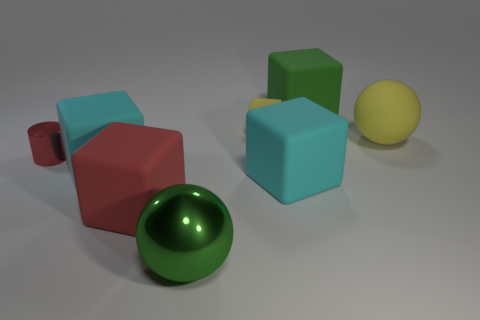Subtract all tiny yellow blocks. How many blocks are left? 4 Subtract all red cubes. How many cubes are left? 4 Subtract 2 blocks. How many blocks are left? 3 Subtract all brown cubes. Subtract all cyan cylinders. How many cubes are left? 5 Add 2 metallic cylinders. How many objects exist? 10 Subtract all cylinders. How many objects are left? 7 Add 7 large yellow objects. How many large yellow objects are left? 8 Add 5 cyan blocks. How many cyan blocks exist? 7 Subtract 0 gray balls. How many objects are left? 8 Subtract all big cyan balls. Subtract all red shiny things. How many objects are left? 7 